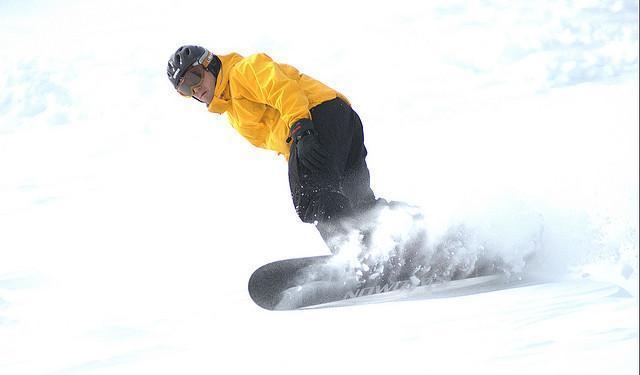How many cars in the left lane?
Give a very brief answer. 0. 